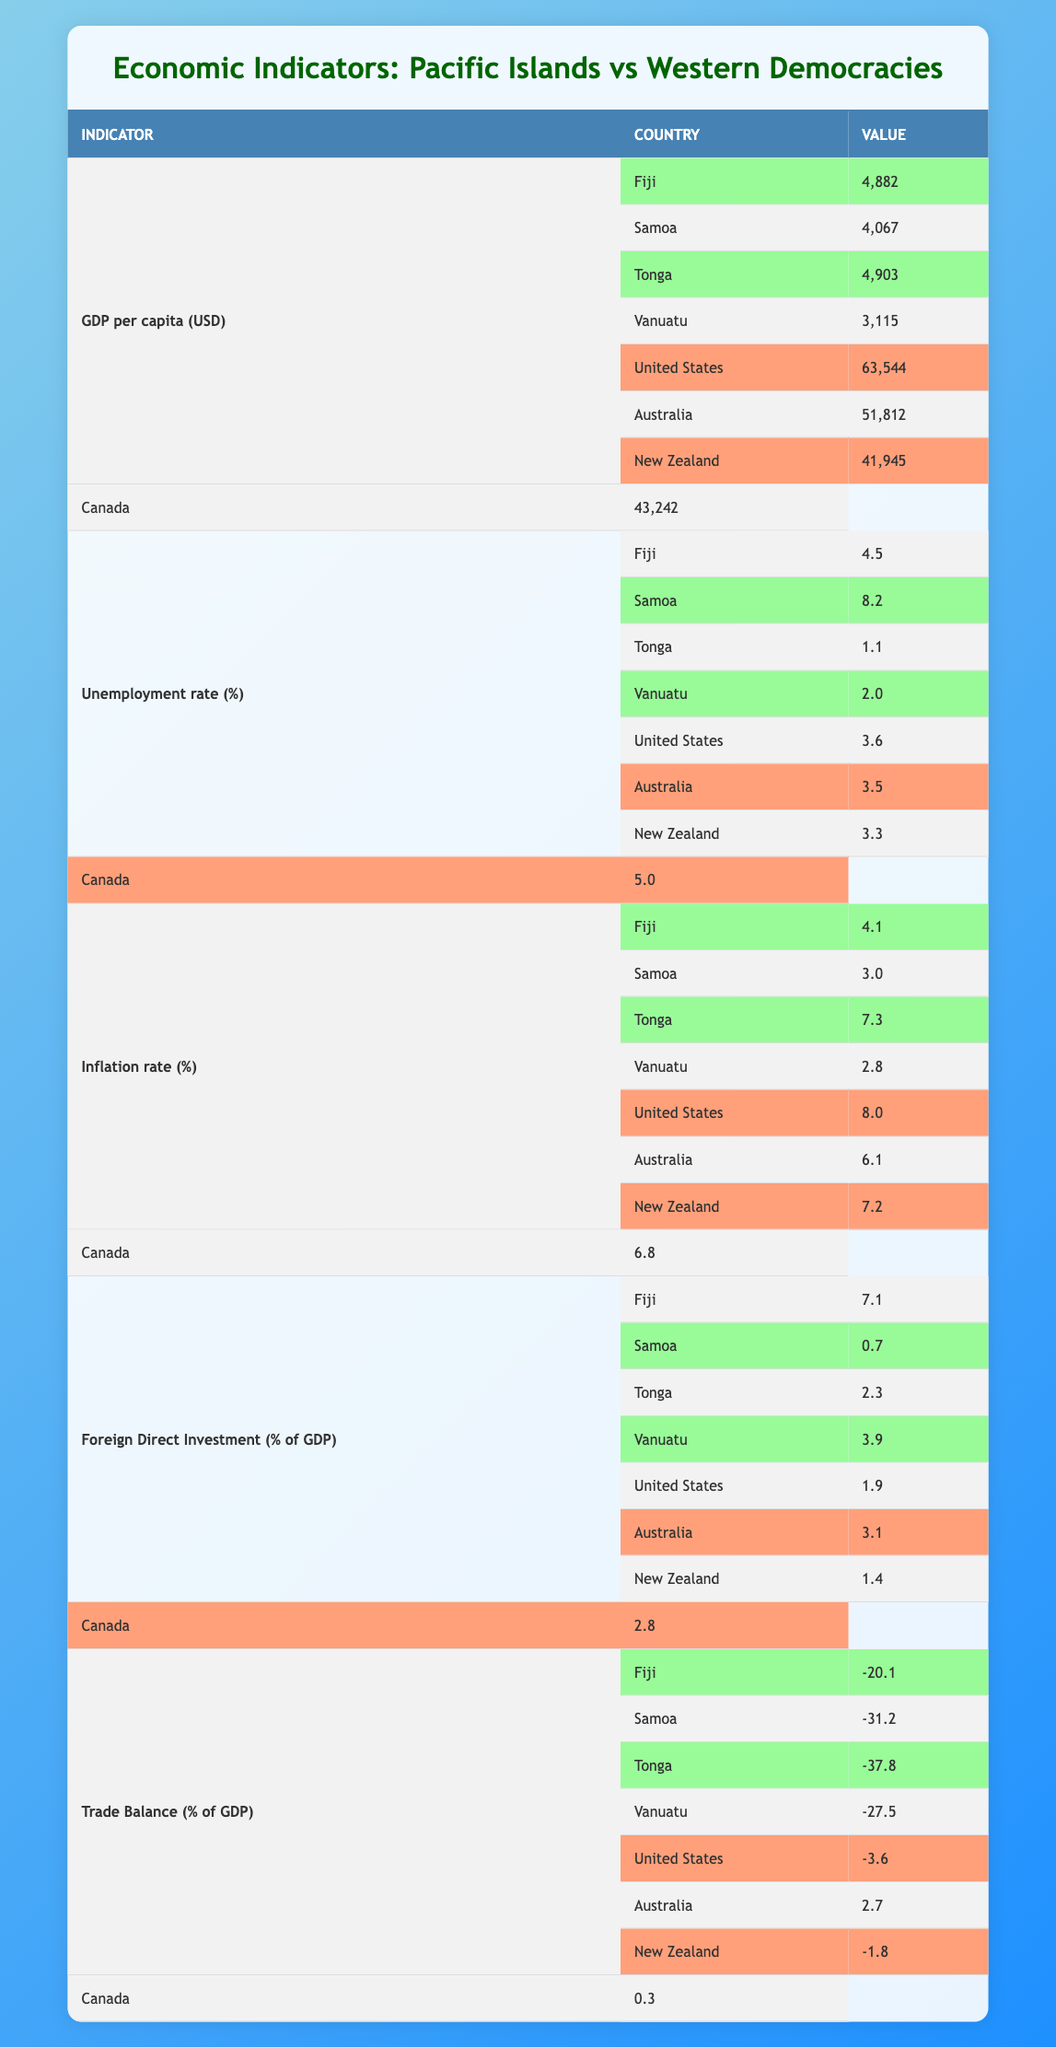What is the GDP per capita for Fiji? According to the table, Fiji's GDP per capita is listed as 4,882 USD.
Answer: 4,882 USD Which Pacific island has the highest unemployment rate? The unemployment rates for the Pacific islands are 4.5% for Fiji, 8.2% for Samoa, 1.1% for Tonga, and 2.0% for Vanuatu. The highest rate among these is for Samoa at 8.2%.
Answer: Samoa Is the inflation rate in Samoa lower than that in the United States? Samoa's inflation rate is 3.0%, while the United States has a rate of 8.0%. Since 3.0% is lower than 8.0%, the statement is true.
Answer: Yes What is the average trade balance for Pacific islands? The trade balances for Fiji, Samoa, Tonga, and Vanuatu are -20.1%, -31.2%, -37.8%, and -27.5%, respectively. The average trade balance is calculated by summing these values and dividing by the number of entries: (-20.1 + -31.2 + -37.8 + -27.5) / 4 = -29.4%.
Answer: -29.4% Which Western democracy has the lowest foreign direct investment as a percentage of GDP? The foreign direct investment percentages for the Western democracies are 1.9% for the United States, 3.1% for Australia, 1.4% for New Zealand, and 2.8% for Canada. Comparing these values, New Zealand has the lowest at 1.4%.
Answer: New Zealand Are the unemployment rates in Australia and Canada higher than those in Tonga? Australia's unemployment rate is 3.5%, Canada's is 5.0%, and Tonga's is 1.1%. Comparing these, both Australia and Canada have higher rates than Tonga's 1.1%, making the statement true.
Answer: Yes What is the difference between the GDP per capita of the United States and that of Vanuatu? The GDP per capita for the United States is 63,544 USD and for Vanuatu is 3,115 USD. The difference is 63,544 - 3,115 = 60,429 USD.
Answer: 60,429 USD Which indicator shows the most significant economic disparity between Pacific islands and Western democracies? Looking at the data, GDP per capita shows the most significant disparity. Fiji's highest GDP per capita of 4,882 USD is considerably lower than the United States' 63,544 USD, indicating a vast gap.
Answer: GDP per capita Is the trade balance for Fiji better than that of Australia? Fiji has a trade balance of -20.1%, while Australia has a trade balance of 2.7%. Since -20.1% is worse than 2.7%, the statement is false.
Answer: No 